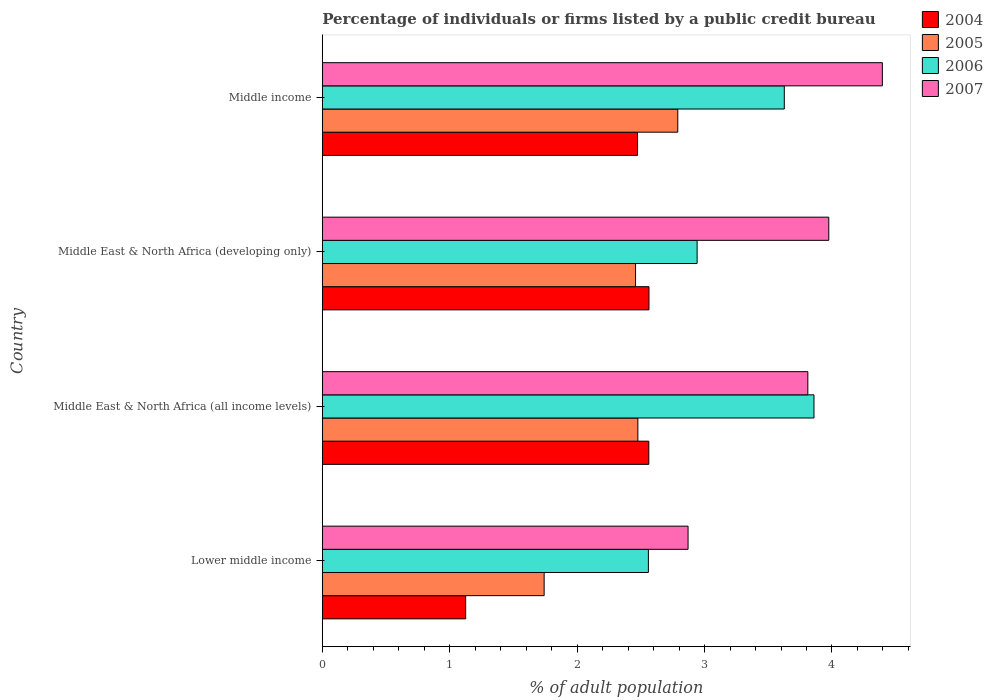How many groups of bars are there?
Make the answer very short. 4. Are the number of bars per tick equal to the number of legend labels?
Offer a very short reply. Yes. What is the label of the 1st group of bars from the top?
Your answer should be compact. Middle income. What is the percentage of population listed by a public credit bureau in 2005 in Lower middle income?
Your response must be concise. 1.74. Across all countries, what is the maximum percentage of population listed by a public credit bureau in 2006?
Your answer should be very brief. 3.86. Across all countries, what is the minimum percentage of population listed by a public credit bureau in 2006?
Your answer should be very brief. 2.56. In which country was the percentage of population listed by a public credit bureau in 2004 minimum?
Your answer should be very brief. Lower middle income. What is the total percentage of population listed by a public credit bureau in 2007 in the graph?
Your response must be concise. 15.05. What is the difference between the percentage of population listed by a public credit bureau in 2004 in Lower middle income and that in Middle East & North Africa (all income levels)?
Your answer should be compact. -1.44. What is the difference between the percentage of population listed by a public credit bureau in 2005 in Middle East & North Africa (all income levels) and the percentage of population listed by a public credit bureau in 2006 in Middle income?
Keep it short and to the point. -1.15. What is the average percentage of population listed by a public credit bureau in 2006 per country?
Offer a terse response. 3.25. What is the difference between the percentage of population listed by a public credit bureau in 2004 and percentage of population listed by a public credit bureau in 2007 in Middle East & North Africa (developing only)?
Provide a succinct answer. -1.41. In how many countries, is the percentage of population listed by a public credit bureau in 2005 greater than 1.8 %?
Keep it short and to the point. 3. What is the ratio of the percentage of population listed by a public credit bureau in 2006 in Lower middle income to that in Middle East & North Africa (developing only)?
Offer a terse response. 0.87. Is the percentage of population listed by a public credit bureau in 2004 in Middle East & North Africa (all income levels) less than that in Middle income?
Keep it short and to the point. No. What is the difference between the highest and the second highest percentage of population listed by a public credit bureau in 2004?
Your answer should be compact. 0. What is the difference between the highest and the lowest percentage of population listed by a public credit bureau in 2007?
Offer a very short reply. 1.53. Is it the case that in every country, the sum of the percentage of population listed by a public credit bureau in 2007 and percentage of population listed by a public credit bureau in 2005 is greater than the sum of percentage of population listed by a public credit bureau in 2006 and percentage of population listed by a public credit bureau in 2004?
Make the answer very short. No. Is it the case that in every country, the sum of the percentage of population listed by a public credit bureau in 2007 and percentage of population listed by a public credit bureau in 2004 is greater than the percentage of population listed by a public credit bureau in 2006?
Make the answer very short. Yes. How many bars are there?
Ensure brevity in your answer.  16. How many countries are there in the graph?
Give a very brief answer. 4. What is the difference between two consecutive major ticks on the X-axis?
Keep it short and to the point. 1. Are the values on the major ticks of X-axis written in scientific E-notation?
Give a very brief answer. No. Does the graph contain any zero values?
Provide a short and direct response. No. Does the graph contain grids?
Keep it short and to the point. No. How many legend labels are there?
Your answer should be compact. 4. How are the legend labels stacked?
Your response must be concise. Vertical. What is the title of the graph?
Your answer should be compact. Percentage of individuals or firms listed by a public credit bureau. What is the label or title of the X-axis?
Provide a succinct answer. % of adult population. What is the % of adult population in 2005 in Lower middle income?
Keep it short and to the point. 1.74. What is the % of adult population in 2006 in Lower middle income?
Your answer should be compact. 2.56. What is the % of adult population in 2007 in Lower middle income?
Make the answer very short. 2.87. What is the % of adult population of 2004 in Middle East & North Africa (all income levels)?
Your answer should be very brief. 2.56. What is the % of adult population of 2005 in Middle East & North Africa (all income levels)?
Provide a succinct answer. 2.48. What is the % of adult population of 2006 in Middle East & North Africa (all income levels)?
Provide a short and direct response. 3.86. What is the % of adult population of 2007 in Middle East & North Africa (all income levels)?
Your answer should be compact. 3.81. What is the % of adult population in 2004 in Middle East & North Africa (developing only)?
Provide a short and direct response. 2.56. What is the % of adult population of 2005 in Middle East & North Africa (developing only)?
Make the answer very short. 2.46. What is the % of adult population in 2006 in Middle East & North Africa (developing only)?
Offer a very short reply. 2.94. What is the % of adult population in 2007 in Middle East & North Africa (developing only)?
Provide a short and direct response. 3.98. What is the % of adult population of 2004 in Middle income?
Your response must be concise. 2.47. What is the % of adult population in 2005 in Middle income?
Your response must be concise. 2.79. What is the % of adult population of 2006 in Middle income?
Give a very brief answer. 3.63. What is the % of adult population of 2007 in Middle income?
Your answer should be compact. 4.4. Across all countries, what is the maximum % of adult population of 2004?
Provide a short and direct response. 2.56. Across all countries, what is the maximum % of adult population in 2005?
Keep it short and to the point. 2.79. Across all countries, what is the maximum % of adult population in 2006?
Keep it short and to the point. 3.86. Across all countries, what is the maximum % of adult population in 2007?
Offer a terse response. 4.4. Across all countries, what is the minimum % of adult population in 2005?
Offer a very short reply. 1.74. Across all countries, what is the minimum % of adult population of 2006?
Your answer should be very brief. 2.56. Across all countries, what is the minimum % of adult population in 2007?
Provide a short and direct response. 2.87. What is the total % of adult population in 2004 in the graph?
Keep it short and to the point. 8.73. What is the total % of adult population in 2005 in the graph?
Your answer should be very brief. 9.47. What is the total % of adult population of 2006 in the graph?
Your response must be concise. 12.99. What is the total % of adult population of 2007 in the graph?
Your answer should be very brief. 15.05. What is the difference between the % of adult population in 2004 in Lower middle income and that in Middle East & North Africa (all income levels)?
Offer a terse response. -1.44. What is the difference between the % of adult population of 2005 in Lower middle income and that in Middle East & North Africa (all income levels)?
Ensure brevity in your answer.  -0.74. What is the difference between the % of adult population in 2006 in Lower middle income and that in Middle East & North Africa (all income levels)?
Your response must be concise. -1.3. What is the difference between the % of adult population of 2007 in Lower middle income and that in Middle East & North Africa (all income levels)?
Make the answer very short. -0.94. What is the difference between the % of adult population in 2004 in Lower middle income and that in Middle East & North Africa (developing only)?
Your response must be concise. -1.44. What is the difference between the % of adult population in 2005 in Lower middle income and that in Middle East & North Africa (developing only)?
Offer a very short reply. -0.72. What is the difference between the % of adult population in 2006 in Lower middle income and that in Middle East & North Africa (developing only)?
Keep it short and to the point. -0.38. What is the difference between the % of adult population of 2007 in Lower middle income and that in Middle East & North Africa (developing only)?
Your answer should be compact. -1.1. What is the difference between the % of adult population in 2004 in Lower middle income and that in Middle income?
Offer a terse response. -1.35. What is the difference between the % of adult population in 2005 in Lower middle income and that in Middle income?
Your answer should be very brief. -1.05. What is the difference between the % of adult population of 2006 in Lower middle income and that in Middle income?
Provide a succinct answer. -1.07. What is the difference between the % of adult population of 2007 in Lower middle income and that in Middle income?
Provide a succinct answer. -1.53. What is the difference between the % of adult population in 2004 in Middle East & North Africa (all income levels) and that in Middle East & North Africa (developing only)?
Your answer should be compact. -0. What is the difference between the % of adult population in 2005 in Middle East & North Africa (all income levels) and that in Middle East & North Africa (developing only)?
Your answer should be compact. 0.02. What is the difference between the % of adult population in 2006 in Middle East & North Africa (all income levels) and that in Middle East & North Africa (developing only)?
Ensure brevity in your answer.  0.92. What is the difference between the % of adult population in 2007 in Middle East & North Africa (all income levels) and that in Middle East & North Africa (developing only)?
Provide a short and direct response. -0.16. What is the difference between the % of adult population of 2004 in Middle East & North Africa (all income levels) and that in Middle income?
Ensure brevity in your answer.  0.09. What is the difference between the % of adult population of 2005 in Middle East & North Africa (all income levels) and that in Middle income?
Your answer should be compact. -0.31. What is the difference between the % of adult population in 2006 in Middle East & North Africa (all income levels) and that in Middle income?
Provide a succinct answer. 0.23. What is the difference between the % of adult population of 2007 in Middle East & North Africa (all income levels) and that in Middle income?
Keep it short and to the point. -0.58. What is the difference between the % of adult population in 2004 in Middle East & North Africa (developing only) and that in Middle income?
Ensure brevity in your answer.  0.09. What is the difference between the % of adult population of 2005 in Middle East & North Africa (developing only) and that in Middle income?
Make the answer very short. -0.33. What is the difference between the % of adult population in 2006 in Middle East & North Africa (developing only) and that in Middle income?
Provide a short and direct response. -0.68. What is the difference between the % of adult population in 2007 in Middle East & North Africa (developing only) and that in Middle income?
Your response must be concise. -0.42. What is the difference between the % of adult population in 2004 in Lower middle income and the % of adult population in 2005 in Middle East & North Africa (all income levels)?
Offer a terse response. -1.35. What is the difference between the % of adult population of 2004 in Lower middle income and the % of adult population of 2006 in Middle East & North Africa (all income levels)?
Keep it short and to the point. -2.73. What is the difference between the % of adult population of 2004 in Lower middle income and the % of adult population of 2007 in Middle East & North Africa (all income levels)?
Keep it short and to the point. -2.69. What is the difference between the % of adult population of 2005 in Lower middle income and the % of adult population of 2006 in Middle East & North Africa (all income levels)?
Make the answer very short. -2.12. What is the difference between the % of adult population of 2005 in Lower middle income and the % of adult population of 2007 in Middle East & North Africa (all income levels)?
Offer a very short reply. -2.07. What is the difference between the % of adult population in 2006 in Lower middle income and the % of adult population in 2007 in Middle East & North Africa (all income levels)?
Offer a very short reply. -1.25. What is the difference between the % of adult population in 2004 in Lower middle income and the % of adult population in 2005 in Middle East & North Africa (developing only)?
Keep it short and to the point. -1.33. What is the difference between the % of adult population of 2004 in Lower middle income and the % of adult population of 2006 in Middle East & North Africa (developing only)?
Your response must be concise. -1.82. What is the difference between the % of adult population of 2004 in Lower middle income and the % of adult population of 2007 in Middle East & North Africa (developing only)?
Provide a succinct answer. -2.85. What is the difference between the % of adult population of 2005 in Lower middle income and the % of adult population of 2006 in Middle East & North Africa (developing only)?
Keep it short and to the point. -1.2. What is the difference between the % of adult population of 2005 in Lower middle income and the % of adult population of 2007 in Middle East & North Africa (developing only)?
Give a very brief answer. -2.23. What is the difference between the % of adult population in 2006 in Lower middle income and the % of adult population in 2007 in Middle East & North Africa (developing only)?
Your answer should be very brief. -1.42. What is the difference between the % of adult population of 2004 in Lower middle income and the % of adult population of 2005 in Middle income?
Provide a short and direct response. -1.66. What is the difference between the % of adult population in 2004 in Lower middle income and the % of adult population in 2006 in Middle income?
Offer a terse response. -2.5. What is the difference between the % of adult population of 2004 in Lower middle income and the % of adult population of 2007 in Middle income?
Offer a very short reply. -3.27. What is the difference between the % of adult population of 2005 in Lower middle income and the % of adult population of 2006 in Middle income?
Ensure brevity in your answer.  -1.88. What is the difference between the % of adult population in 2005 in Lower middle income and the % of adult population in 2007 in Middle income?
Your answer should be very brief. -2.65. What is the difference between the % of adult population in 2006 in Lower middle income and the % of adult population in 2007 in Middle income?
Give a very brief answer. -1.84. What is the difference between the % of adult population in 2004 in Middle East & North Africa (all income levels) and the % of adult population in 2005 in Middle East & North Africa (developing only)?
Give a very brief answer. 0.1. What is the difference between the % of adult population in 2004 in Middle East & North Africa (all income levels) and the % of adult population in 2006 in Middle East & North Africa (developing only)?
Offer a terse response. -0.38. What is the difference between the % of adult population in 2004 in Middle East & North Africa (all income levels) and the % of adult population in 2007 in Middle East & North Africa (developing only)?
Give a very brief answer. -1.41. What is the difference between the % of adult population of 2005 in Middle East & North Africa (all income levels) and the % of adult population of 2006 in Middle East & North Africa (developing only)?
Your response must be concise. -0.47. What is the difference between the % of adult population of 2005 in Middle East & North Africa (all income levels) and the % of adult population of 2007 in Middle East & North Africa (developing only)?
Offer a terse response. -1.5. What is the difference between the % of adult population in 2006 in Middle East & North Africa (all income levels) and the % of adult population in 2007 in Middle East & North Africa (developing only)?
Your response must be concise. -0.12. What is the difference between the % of adult population of 2004 in Middle East & North Africa (all income levels) and the % of adult population of 2005 in Middle income?
Offer a terse response. -0.23. What is the difference between the % of adult population of 2004 in Middle East & North Africa (all income levels) and the % of adult population of 2006 in Middle income?
Keep it short and to the point. -1.06. What is the difference between the % of adult population of 2004 in Middle East & North Africa (all income levels) and the % of adult population of 2007 in Middle income?
Provide a short and direct response. -1.83. What is the difference between the % of adult population in 2005 in Middle East & North Africa (all income levels) and the % of adult population in 2006 in Middle income?
Provide a short and direct response. -1.15. What is the difference between the % of adult population in 2005 in Middle East & North Africa (all income levels) and the % of adult population in 2007 in Middle income?
Make the answer very short. -1.92. What is the difference between the % of adult population of 2006 in Middle East & North Africa (all income levels) and the % of adult population of 2007 in Middle income?
Your response must be concise. -0.54. What is the difference between the % of adult population in 2004 in Middle East & North Africa (developing only) and the % of adult population in 2005 in Middle income?
Your answer should be very brief. -0.23. What is the difference between the % of adult population of 2004 in Middle East & North Africa (developing only) and the % of adult population of 2006 in Middle income?
Your answer should be very brief. -1.06. What is the difference between the % of adult population of 2004 in Middle East & North Africa (developing only) and the % of adult population of 2007 in Middle income?
Keep it short and to the point. -1.83. What is the difference between the % of adult population in 2005 in Middle East & North Africa (developing only) and the % of adult population in 2006 in Middle income?
Make the answer very short. -1.17. What is the difference between the % of adult population of 2005 in Middle East & North Africa (developing only) and the % of adult population of 2007 in Middle income?
Provide a short and direct response. -1.94. What is the difference between the % of adult population of 2006 in Middle East & North Africa (developing only) and the % of adult population of 2007 in Middle income?
Your answer should be very brief. -1.45. What is the average % of adult population of 2004 per country?
Your answer should be compact. 2.18. What is the average % of adult population in 2005 per country?
Provide a succinct answer. 2.37. What is the average % of adult population of 2006 per country?
Ensure brevity in your answer.  3.25. What is the average % of adult population of 2007 per country?
Make the answer very short. 3.76. What is the difference between the % of adult population in 2004 and % of adult population in 2005 in Lower middle income?
Make the answer very short. -0.62. What is the difference between the % of adult population of 2004 and % of adult population of 2006 in Lower middle income?
Offer a very short reply. -1.43. What is the difference between the % of adult population in 2004 and % of adult population in 2007 in Lower middle income?
Ensure brevity in your answer.  -1.75. What is the difference between the % of adult population of 2005 and % of adult population of 2006 in Lower middle income?
Your response must be concise. -0.82. What is the difference between the % of adult population in 2005 and % of adult population in 2007 in Lower middle income?
Your answer should be very brief. -1.13. What is the difference between the % of adult population in 2006 and % of adult population in 2007 in Lower middle income?
Your answer should be compact. -0.31. What is the difference between the % of adult population in 2004 and % of adult population in 2005 in Middle East & North Africa (all income levels)?
Your response must be concise. 0.09. What is the difference between the % of adult population of 2004 and % of adult population of 2006 in Middle East & North Africa (all income levels)?
Keep it short and to the point. -1.3. What is the difference between the % of adult population in 2004 and % of adult population in 2007 in Middle East & North Africa (all income levels)?
Your response must be concise. -1.25. What is the difference between the % of adult population in 2005 and % of adult population in 2006 in Middle East & North Africa (all income levels)?
Your response must be concise. -1.38. What is the difference between the % of adult population in 2005 and % of adult population in 2007 in Middle East & North Africa (all income levels)?
Give a very brief answer. -1.33. What is the difference between the % of adult population in 2006 and % of adult population in 2007 in Middle East & North Africa (all income levels)?
Provide a short and direct response. 0.05. What is the difference between the % of adult population in 2004 and % of adult population in 2005 in Middle East & North Africa (developing only)?
Give a very brief answer. 0.11. What is the difference between the % of adult population of 2004 and % of adult population of 2006 in Middle East & North Africa (developing only)?
Give a very brief answer. -0.38. What is the difference between the % of adult population of 2004 and % of adult population of 2007 in Middle East & North Africa (developing only)?
Make the answer very short. -1.41. What is the difference between the % of adult population of 2005 and % of adult population of 2006 in Middle East & North Africa (developing only)?
Provide a succinct answer. -0.48. What is the difference between the % of adult population of 2005 and % of adult population of 2007 in Middle East & North Africa (developing only)?
Provide a succinct answer. -1.52. What is the difference between the % of adult population in 2006 and % of adult population in 2007 in Middle East & North Africa (developing only)?
Offer a very short reply. -1.03. What is the difference between the % of adult population of 2004 and % of adult population of 2005 in Middle income?
Your answer should be compact. -0.32. What is the difference between the % of adult population in 2004 and % of adult population in 2006 in Middle income?
Your answer should be very brief. -1.15. What is the difference between the % of adult population in 2004 and % of adult population in 2007 in Middle income?
Offer a very short reply. -1.92. What is the difference between the % of adult population in 2005 and % of adult population in 2006 in Middle income?
Offer a terse response. -0.84. What is the difference between the % of adult population in 2005 and % of adult population in 2007 in Middle income?
Offer a very short reply. -1.61. What is the difference between the % of adult population in 2006 and % of adult population in 2007 in Middle income?
Give a very brief answer. -0.77. What is the ratio of the % of adult population of 2004 in Lower middle income to that in Middle East & North Africa (all income levels)?
Provide a short and direct response. 0.44. What is the ratio of the % of adult population in 2005 in Lower middle income to that in Middle East & North Africa (all income levels)?
Your answer should be very brief. 0.7. What is the ratio of the % of adult population in 2006 in Lower middle income to that in Middle East & North Africa (all income levels)?
Keep it short and to the point. 0.66. What is the ratio of the % of adult population in 2007 in Lower middle income to that in Middle East & North Africa (all income levels)?
Keep it short and to the point. 0.75. What is the ratio of the % of adult population in 2004 in Lower middle income to that in Middle East & North Africa (developing only)?
Ensure brevity in your answer.  0.44. What is the ratio of the % of adult population in 2005 in Lower middle income to that in Middle East & North Africa (developing only)?
Make the answer very short. 0.71. What is the ratio of the % of adult population in 2006 in Lower middle income to that in Middle East & North Africa (developing only)?
Make the answer very short. 0.87. What is the ratio of the % of adult population in 2007 in Lower middle income to that in Middle East & North Africa (developing only)?
Offer a very short reply. 0.72. What is the ratio of the % of adult population in 2004 in Lower middle income to that in Middle income?
Provide a short and direct response. 0.45. What is the ratio of the % of adult population of 2005 in Lower middle income to that in Middle income?
Provide a succinct answer. 0.62. What is the ratio of the % of adult population of 2006 in Lower middle income to that in Middle income?
Provide a short and direct response. 0.71. What is the ratio of the % of adult population in 2007 in Lower middle income to that in Middle income?
Provide a succinct answer. 0.65. What is the ratio of the % of adult population of 2004 in Middle East & North Africa (all income levels) to that in Middle East & North Africa (developing only)?
Keep it short and to the point. 1. What is the ratio of the % of adult population of 2005 in Middle East & North Africa (all income levels) to that in Middle East & North Africa (developing only)?
Offer a terse response. 1.01. What is the ratio of the % of adult population in 2006 in Middle East & North Africa (all income levels) to that in Middle East & North Africa (developing only)?
Give a very brief answer. 1.31. What is the ratio of the % of adult population in 2007 in Middle East & North Africa (all income levels) to that in Middle East & North Africa (developing only)?
Offer a terse response. 0.96. What is the ratio of the % of adult population of 2004 in Middle East & North Africa (all income levels) to that in Middle income?
Give a very brief answer. 1.04. What is the ratio of the % of adult population of 2005 in Middle East & North Africa (all income levels) to that in Middle income?
Provide a succinct answer. 0.89. What is the ratio of the % of adult population in 2006 in Middle East & North Africa (all income levels) to that in Middle income?
Offer a terse response. 1.06. What is the ratio of the % of adult population in 2007 in Middle East & North Africa (all income levels) to that in Middle income?
Offer a very short reply. 0.87. What is the ratio of the % of adult population of 2004 in Middle East & North Africa (developing only) to that in Middle income?
Provide a succinct answer. 1.04. What is the ratio of the % of adult population of 2005 in Middle East & North Africa (developing only) to that in Middle income?
Keep it short and to the point. 0.88. What is the ratio of the % of adult population in 2006 in Middle East & North Africa (developing only) to that in Middle income?
Ensure brevity in your answer.  0.81. What is the ratio of the % of adult population of 2007 in Middle East & North Africa (developing only) to that in Middle income?
Ensure brevity in your answer.  0.9. What is the difference between the highest and the second highest % of adult population of 2004?
Your response must be concise. 0. What is the difference between the highest and the second highest % of adult population of 2005?
Make the answer very short. 0.31. What is the difference between the highest and the second highest % of adult population in 2006?
Provide a succinct answer. 0.23. What is the difference between the highest and the second highest % of adult population in 2007?
Your response must be concise. 0.42. What is the difference between the highest and the lowest % of adult population of 2004?
Provide a short and direct response. 1.44. What is the difference between the highest and the lowest % of adult population of 2005?
Provide a succinct answer. 1.05. What is the difference between the highest and the lowest % of adult population of 2006?
Give a very brief answer. 1.3. What is the difference between the highest and the lowest % of adult population in 2007?
Make the answer very short. 1.53. 